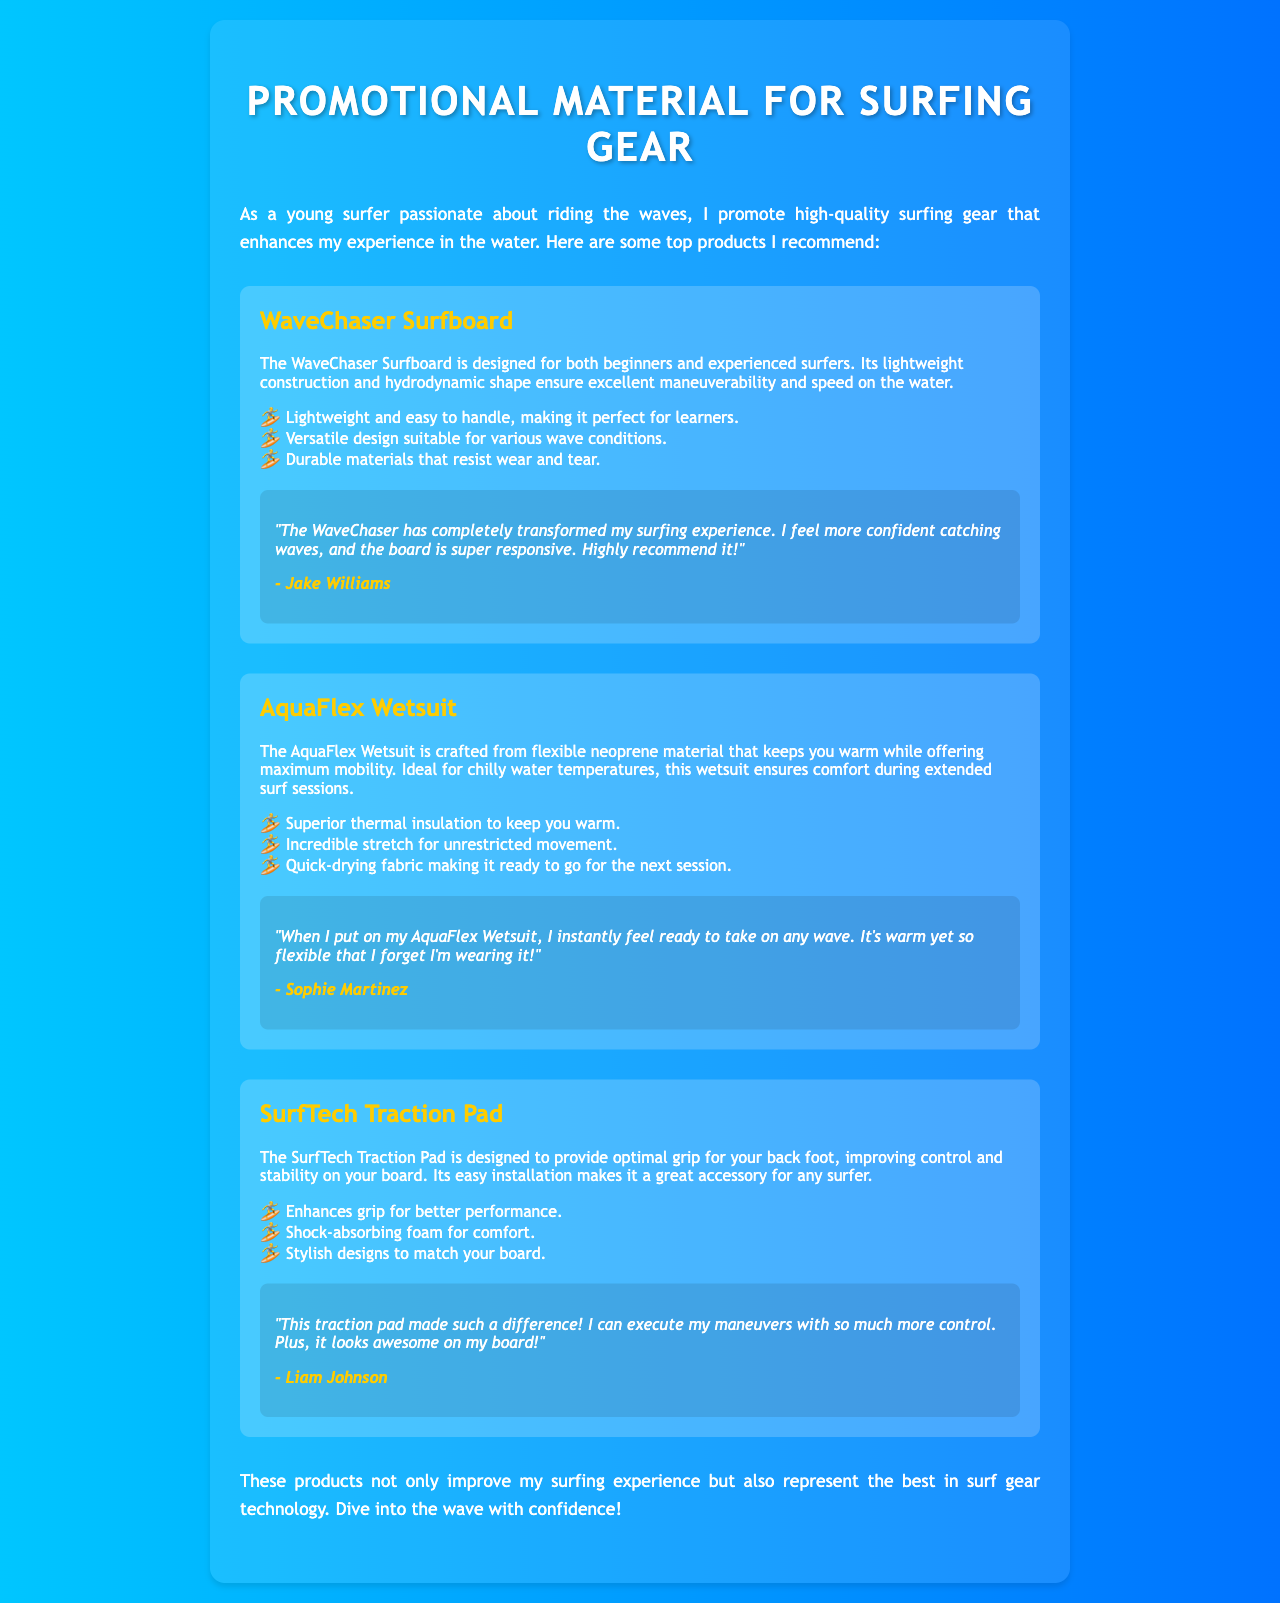What is the name of the first product? The first product listed in the document is the WaveChaser Surfboard.
Answer: WaveChaser Surfboard What material is the AquaFlex Wetsuit made from? The AquaFlex Wetsuit is crafted from flexible neoprene material.
Answer: Neoprene What benefit does the SurfTech Traction Pad provide? The SurfTech Traction Pad enhances grip for better performance.
Answer: Enhances grip Who is the user that provided feedback on the AquaFlex Wetsuit? The user who provided feedback on the AquaFlex Wetsuit is Sophie Martinez.
Answer: Sophie Martinez What is a feature of the WaveChaser Surfboard? A feature of the WaveChaser Surfboard is its lightweight construction.
Answer: Lightweight construction How does the AquaFlex Wetsuit contribute to comfort? The AquaFlex Wetsuit offers incredible stretch for unrestricted movement.
Answer: Incredible stretch What is the main advantage of the SurfTech Traction Pad according to the user? According to the user, the main advantage is improved control for maneuvers.
Answer: Improved control What type of material is used in the AquaFlex Wetsuit for thermal insulation? The AquaFlex Wetsuit uses superior thermal insulation to keep you warm.
Answer: Superior thermal insulation 